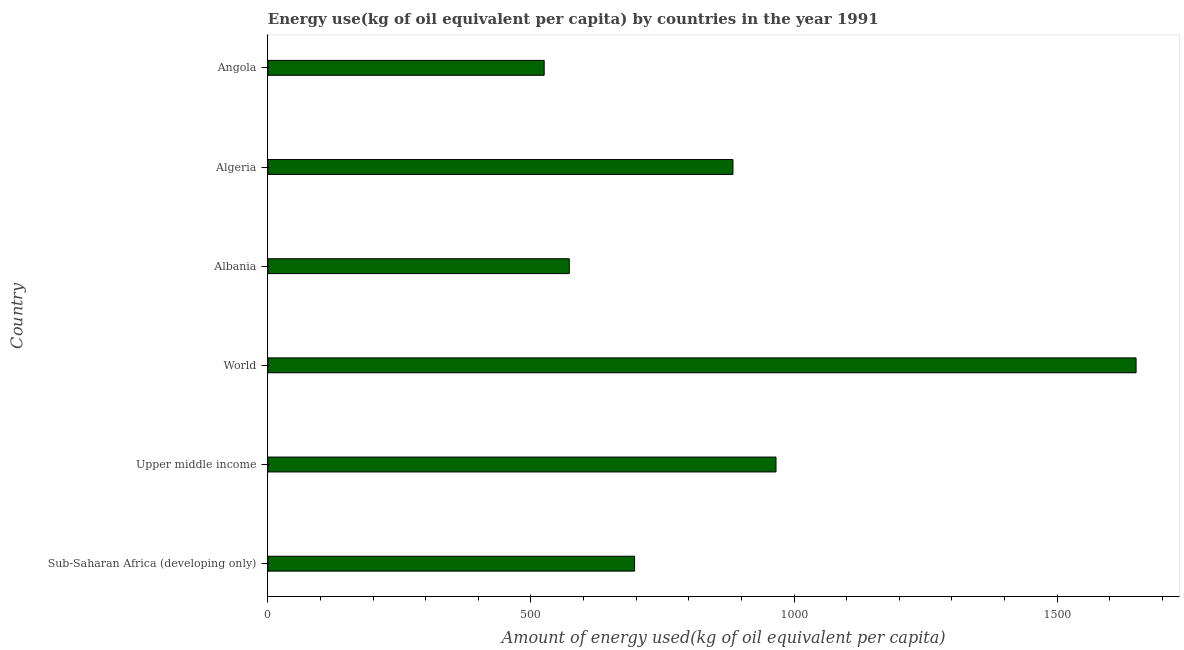Does the graph contain grids?
Ensure brevity in your answer.  No. What is the title of the graph?
Provide a succinct answer. Energy use(kg of oil equivalent per capita) by countries in the year 1991. What is the label or title of the X-axis?
Provide a succinct answer. Amount of energy used(kg of oil equivalent per capita). What is the amount of energy used in Sub-Saharan Africa (developing only)?
Give a very brief answer. 696.9. Across all countries, what is the maximum amount of energy used?
Provide a succinct answer. 1649.87. Across all countries, what is the minimum amount of energy used?
Make the answer very short. 525.1. In which country was the amount of energy used maximum?
Keep it short and to the point. World. In which country was the amount of energy used minimum?
Provide a succinct answer. Angola. What is the sum of the amount of energy used?
Your answer should be compact. 5294.08. What is the difference between the amount of energy used in Upper middle income and World?
Ensure brevity in your answer.  -684.25. What is the average amount of energy used per country?
Provide a short and direct response. 882.35. What is the median amount of energy used?
Ensure brevity in your answer.  790.36. In how many countries, is the amount of energy used greater than 500 kg?
Give a very brief answer. 6. What is the ratio of the amount of energy used in Sub-Saharan Africa (developing only) to that in Upper middle income?
Your response must be concise. 0.72. What is the difference between the highest and the second highest amount of energy used?
Your response must be concise. 684.25. Is the sum of the amount of energy used in Algeria and Angola greater than the maximum amount of energy used across all countries?
Give a very brief answer. No. What is the difference between the highest and the lowest amount of energy used?
Your answer should be very brief. 1124.76. Are all the bars in the graph horizontal?
Keep it short and to the point. Yes. What is the difference between two consecutive major ticks on the X-axis?
Give a very brief answer. 500. What is the Amount of energy used(kg of oil equivalent per capita) of Sub-Saharan Africa (developing only)?
Give a very brief answer. 696.9. What is the Amount of energy used(kg of oil equivalent per capita) in Upper middle income?
Your answer should be compact. 965.62. What is the Amount of energy used(kg of oil equivalent per capita) of World?
Keep it short and to the point. 1649.87. What is the Amount of energy used(kg of oil equivalent per capita) in Albania?
Your answer should be very brief. 572.78. What is the Amount of energy used(kg of oil equivalent per capita) of Algeria?
Offer a terse response. 883.82. What is the Amount of energy used(kg of oil equivalent per capita) in Angola?
Your answer should be very brief. 525.1. What is the difference between the Amount of energy used(kg of oil equivalent per capita) in Sub-Saharan Africa (developing only) and Upper middle income?
Offer a terse response. -268.72. What is the difference between the Amount of energy used(kg of oil equivalent per capita) in Sub-Saharan Africa (developing only) and World?
Your answer should be compact. -952.97. What is the difference between the Amount of energy used(kg of oil equivalent per capita) in Sub-Saharan Africa (developing only) and Albania?
Your answer should be very brief. 124.11. What is the difference between the Amount of energy used(kg of oil equivalent per capita) in Sub-Saharan Africa (developing only) and Algeria?
Your answer should be compact. -186.93. What is the difference between the Amount of energy used(kg of oil equivalent per capita) in Sub-Saharan Africa (developing only) and Angola?
Offer a very short reply. 171.8. What is the difference between the Amount of energy used(kg of oil equivalent per capita) in Upper middle income and World?
Ensure brevity in your answer.  -684.25. What is the difference between the Amount of energy used(kg of oil equivalent per capita) in Upper middle income and Albania?
Give a very brief answer. 392.84. What is the difference between the Amount of energy used(kg of oil equivalent per capita) in Upper middle income and Algeria?
Keep it short and to the point. 81.8. What is the difference between the Amount of energy used(kg of oil equivalent per capita) in Upper middle income and Angola?
Your answer should be compact. 440.52. What is the difference between the Amount of energy used(kg of oil equivalent per capita) in World and Albania?
Ensure brevity in your answer.  1077.08. What is the difference between the Amount of energy used(kg of oil equivalent per capita) in World and Algeria?
Give a very brief answer. 766.04. What is the difference between the Amount of energy used(kg of oil equivalent per capita) in World and Angola?
Make the answer very short. 1124.76. What is the difference between the Amount of energy used(kg of oil equivalent per capita) in Albania and Algeria?
Keep it short and to the point. -311.04. What is the difference between the Amount of energy used(kg of oil equivalent per capita) in Albania and Angola?
Offer a very short reply. 47.68. What is the difference between the Amount of energy used(kg of oil equivalent per capita) in Algeria and Angola?
Make the answer very short. 358.72. What is the ratio of the Amount of energy used(kg of oil equivalent per capita) in Sub-Saharan Africa (developing only) to that in Upper middle income?
Give a very brief answer. 0.72. What is the ratio of the Amount of energy used(kg of oil equivalent per capita) in Sub-Saharan Africa (developing only) to that in World?
Ensure brevity in your answer.  0.42. What is the ratio of the Amount of energy used(kg of oil equivalent per capita) in Sub-Saharan Africa (developing only) to that in Albania?
Ensure brevity in your answer.  1.22. What is the ratio of the Amount of energy used(kg of oil equivalent per capita) in Sub-Saharan Africa (developing only) to that in Algeria?
Give a very brief answer. 0.79. What is the ratio of the Amount of energy used(kg of oil equivalent per capita) in Sub-Saharan Africa (developing only) to that in Angola?
Offer a very short reply. 1.33. What is the ratio of the Amount of energy used(kg of oil equivalent per capita) in Upper middle income to that in World?
Your response must be concise. 0.58. What is the ratio of the Amount of energy used(kg of oil equivalent per capita) in Upper middle income to that in Albania?
Offer a very short reply. 1.69. What is the ratio of the Amount of energy used(kg of oil equivalent per capita) in Upper middle income to that in Algeria?
Provide a succinct answer. 1.09. What is the ratio of the Amount of energy used(kg of oil equivalent per capita) in Upper middle income to that in Angola?
Provide a short and direct response. 1.84. What is the ratio of the Amount of energy used(kg of oil equivalent per capita) in World to that in Albania?
Ensure brevity in your answer.  2.88. What is the ratio of the Amount of energy used(kg of oil equivalent per capita) in World to that in Algeria?
Make the answer very short. 1.87. What is the ratio of the Amount of energy used(kg of oil equivalent per capita) in World to that in Angola?
Your response must be concise. 3.14. What is the ratio of the Amount of energy used(kg of oil equivalent per capita) in Albania to that in Algeria?
Your response must be concise. 0.65. What is the ratio of the Amount of energy used(kg of oil equivalent per capita) in Albania to that in Angola?
Provide a short and direct response. 1.09. What is the ratio of the Amount of energy used(kg of oil equivalent per capita) in Algeria to that in Angola?
Offer a terse response. 1.68. 